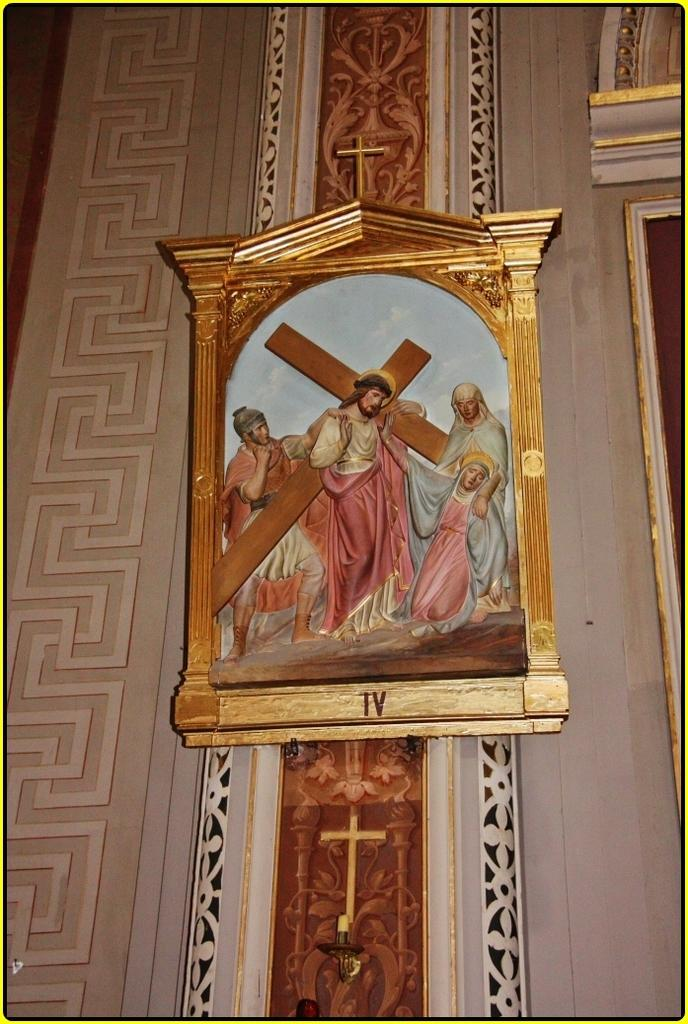<image>
Create a compact narrative representing the image presented. A picture of Jesus carrying a cross is labeled with the Roman numbers IV. 